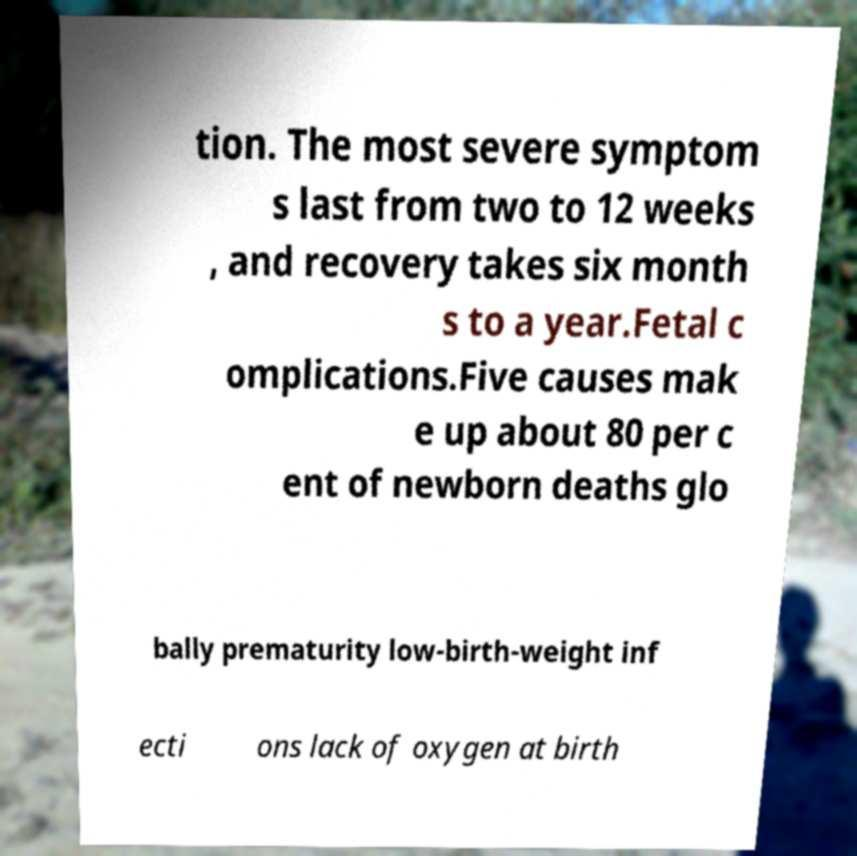Please identify and transcribe the text found in this image. tion. The most severe symptom s last from two to 12 weeks , and recovery takes six month s to a year.Fetal c omplications.Five causes mak e up about 80 per c ent of newborn deaths glo bally prematurity low-birth-weight inf ecti ons lack of oxygen at birth 